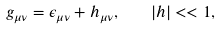<formula> <loc_0><loc_0><loc_500><loc_500>g _ { \mu \nu } = \epsilon _ { \mu \nu } + h _ { \mu \nu } , \quad | h | < < 1 ,</formula> 